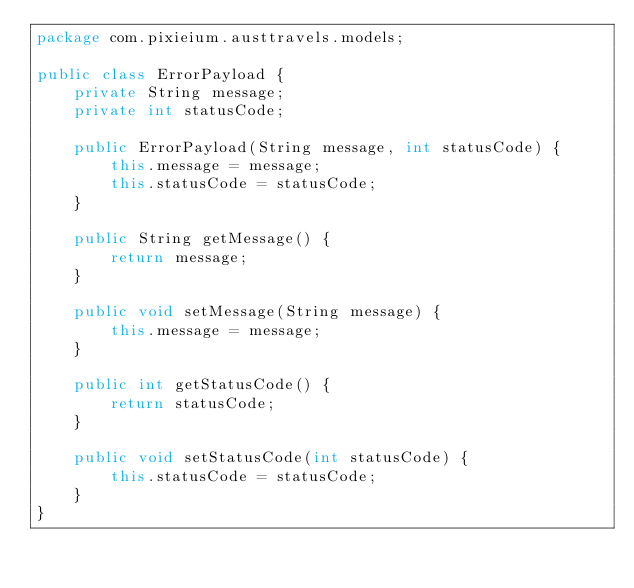Convert code to text. <code><loc_0><loc_0><loc_500><loc_500><_Java_>package com.pixieium.austtravels.models;

public class ErrorPayload {
    private String message;
    private int statusCode;

    public ErrorPayload(String message, int statusCode) {
        this.message = message;
        this.statusCode = statusCode;
    }

    public String getMessage() {
        return message;
    }

    public void setMessage(String message) {
        this.message = message;
    }

    public int getStatusCode() {
        return statusCode;
    }

    public void setStatusCode(int statusCode) {
        this.statusCode = statusCode;
    }
}
</code> 